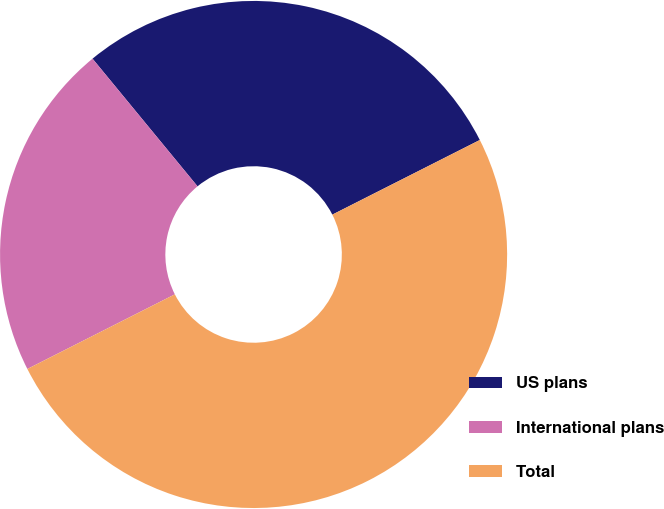Convert chart. <chart><loc_0><loc_0><loc_500><loc_500><pie_chart><fcel>US plans<fcel>International plans<fcel>Total<nl><fcel>28.5%<fcel>21.5%<fcel>50.0%<nl></chart> 